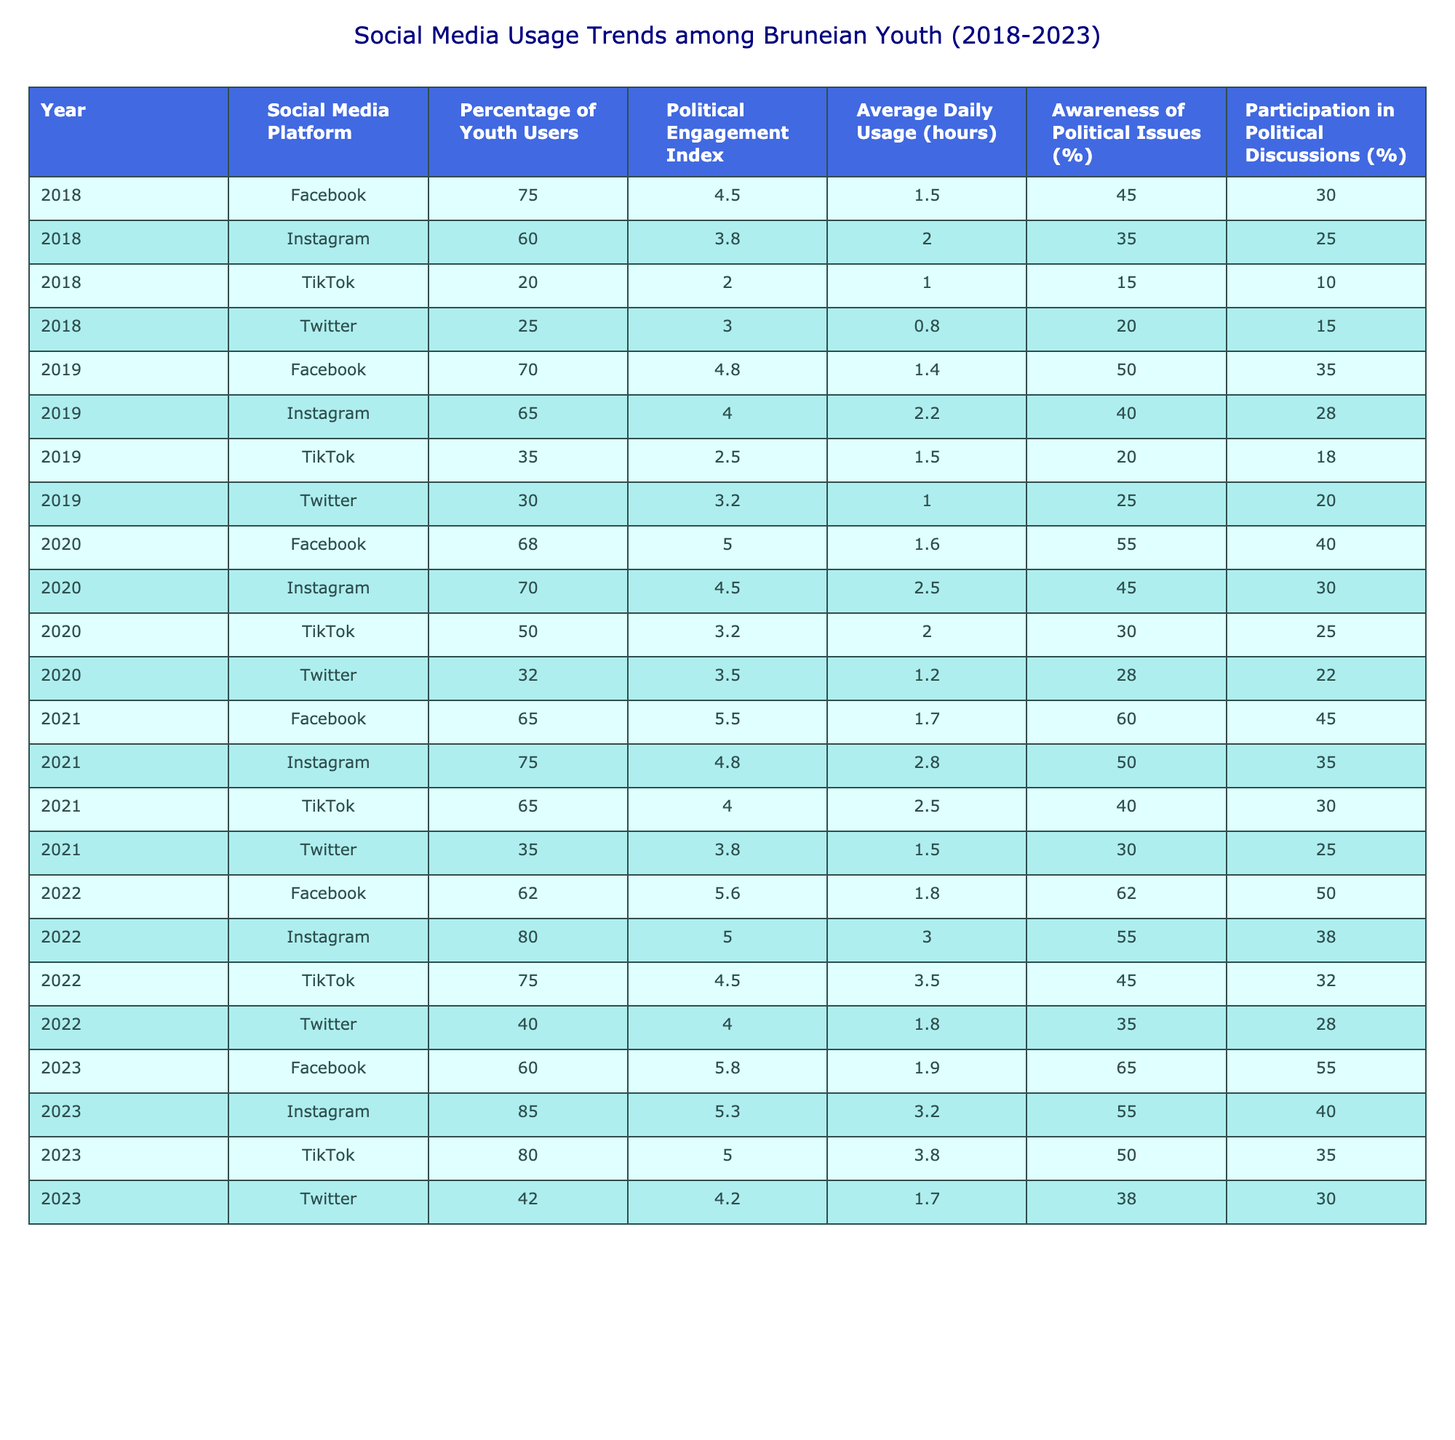What was the percentage of youth users on Instagram in 2021? Looking at the row for 2021 and the column for Instagram, the percentage is listed as 75%.
Answer: 75% Which social media platform had the highest Political Engagement Index in 2022? In the year 2022, the Political Engagement Index for the platforms were: Facebook (5.6), Instagram (5.0), TikTok (4.5), and Twitter (4.0). Among these, Facebook has the highest index at 5.6.
Answer: Facebook What was the average daily usage of TikTok by Bruneian youth in 2020? Referring to the 2020 row for TikTok, the Average Daily Usage is 2.0 hours.
Answer: 2.0 hours Did the awareness of political issues among youth increase from 2018 to 2023? By checking the Awareness of Political Issues column: 2018 (45%), 2019 (50%), 2020 (55%), 2021 (60%), 2022 (62%), and 2023 (65%), it can be confirmed that there was an increase over the years.
Answer: Yes What is the difference in the percentage of youth users on Facebook between 2019 and 2023? The percentage of youth users on Facebook in 2019 is 70%, and in 2023 is 60%. The difference is 70 - 60 = 10%.
Answer: 10% In which year did Instagram have the highest percentage of youth users? By examining the percentages for Instagram: 2018 (60%), 2019 (65%), 2020 (70%), 2021 (75%), 2022 (80%), and 2023 (85%), it is evident that 2023 has the highest percentage at 85%.
Answer: 2023 What was the trend in average daily usage hours for Twitter from 2018 to 2023? The average daily usage for Twitter in the years are: 2018 (0.8), 2019 (1.0), 2020 (1.2), 2021 (1.5), 2022 (1.8), and 2023 (1.7). This shows that usage increased from 2018 to 2022, then slightly decreased in 2023.
Answer: Increased then decreased Which platform had the lowest awareness of political issues in 2019? Checking the column for Awareness of Political Issues for 2019: Facebook (50%), Instagram (40%), TikTok (20%), Twitter (25%). TikTok has the lowest value at 20%.
Answer: TikTok What is the average Political Engagement Index for all platforms in 2022? The Political Engagement Index values for 2022 are: Facebook (5.6), Instagram (5.0), TikTok (4.5), and Twitter (4.0). The sum is 5.6 + 5.0 + 4.5 + 4.0 = 19.1, and there are 4 platforms, so the average is 19.1 / 4 = 4.775.
Answer: 4.775 